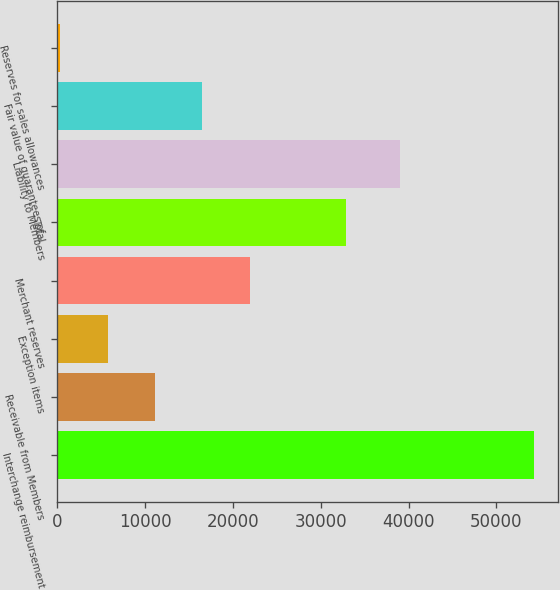<chart> <loc_0><loc_0><loc_500><loc_500><bar_chart><fcel>Interchange reimbursement<fcel>Receivable from Members<fcel>Exception items<fcel>Merchant reserves<fcel>Total<fcel>Liability to Members<fcel>Fair value of guarantees of<fcel>Reserves for sales allowances<nl><fcel>54279<fcel>11118.2<fcel>5723.1<fcel>21908.4<fcel>32853<fcel>38986<fcel>16513.3<fcel>328<nl></chart> 